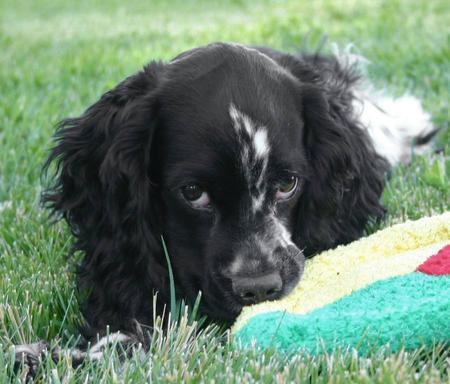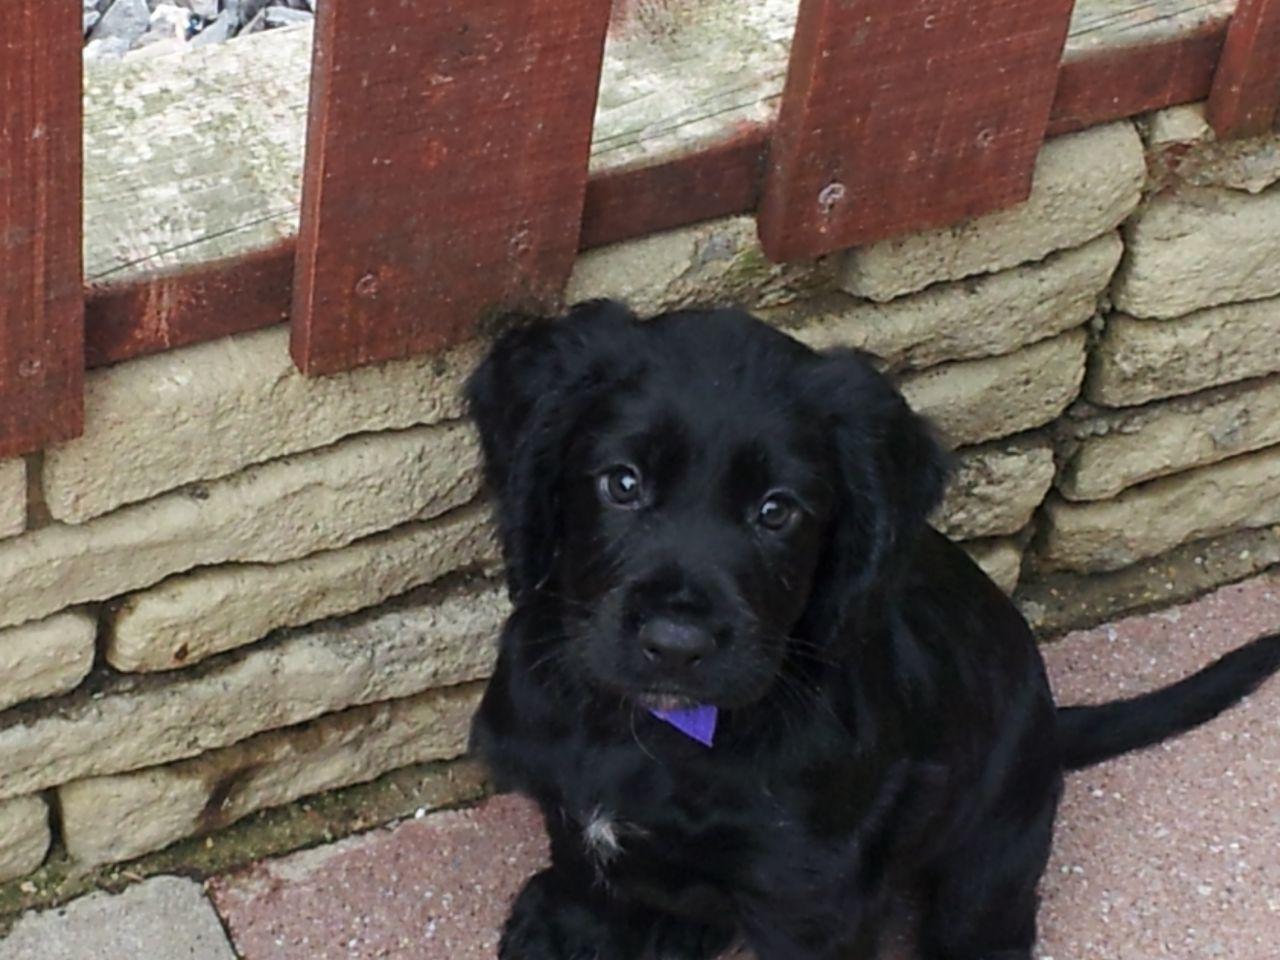The first image is the image on the left, the second image is the image on the right. For the images displayed, is the sentence "The black dog in the image on the left is outside in the grass." factually correct? Answer yes or no. Yes. The first image is the image on the left, the second image is the image on the right. Analyze the images presented: Is the assertion "An image shows a black-faced dog posed on green grass, touching some type of toy in front of it." valid? Answer yes or no. Yes. 